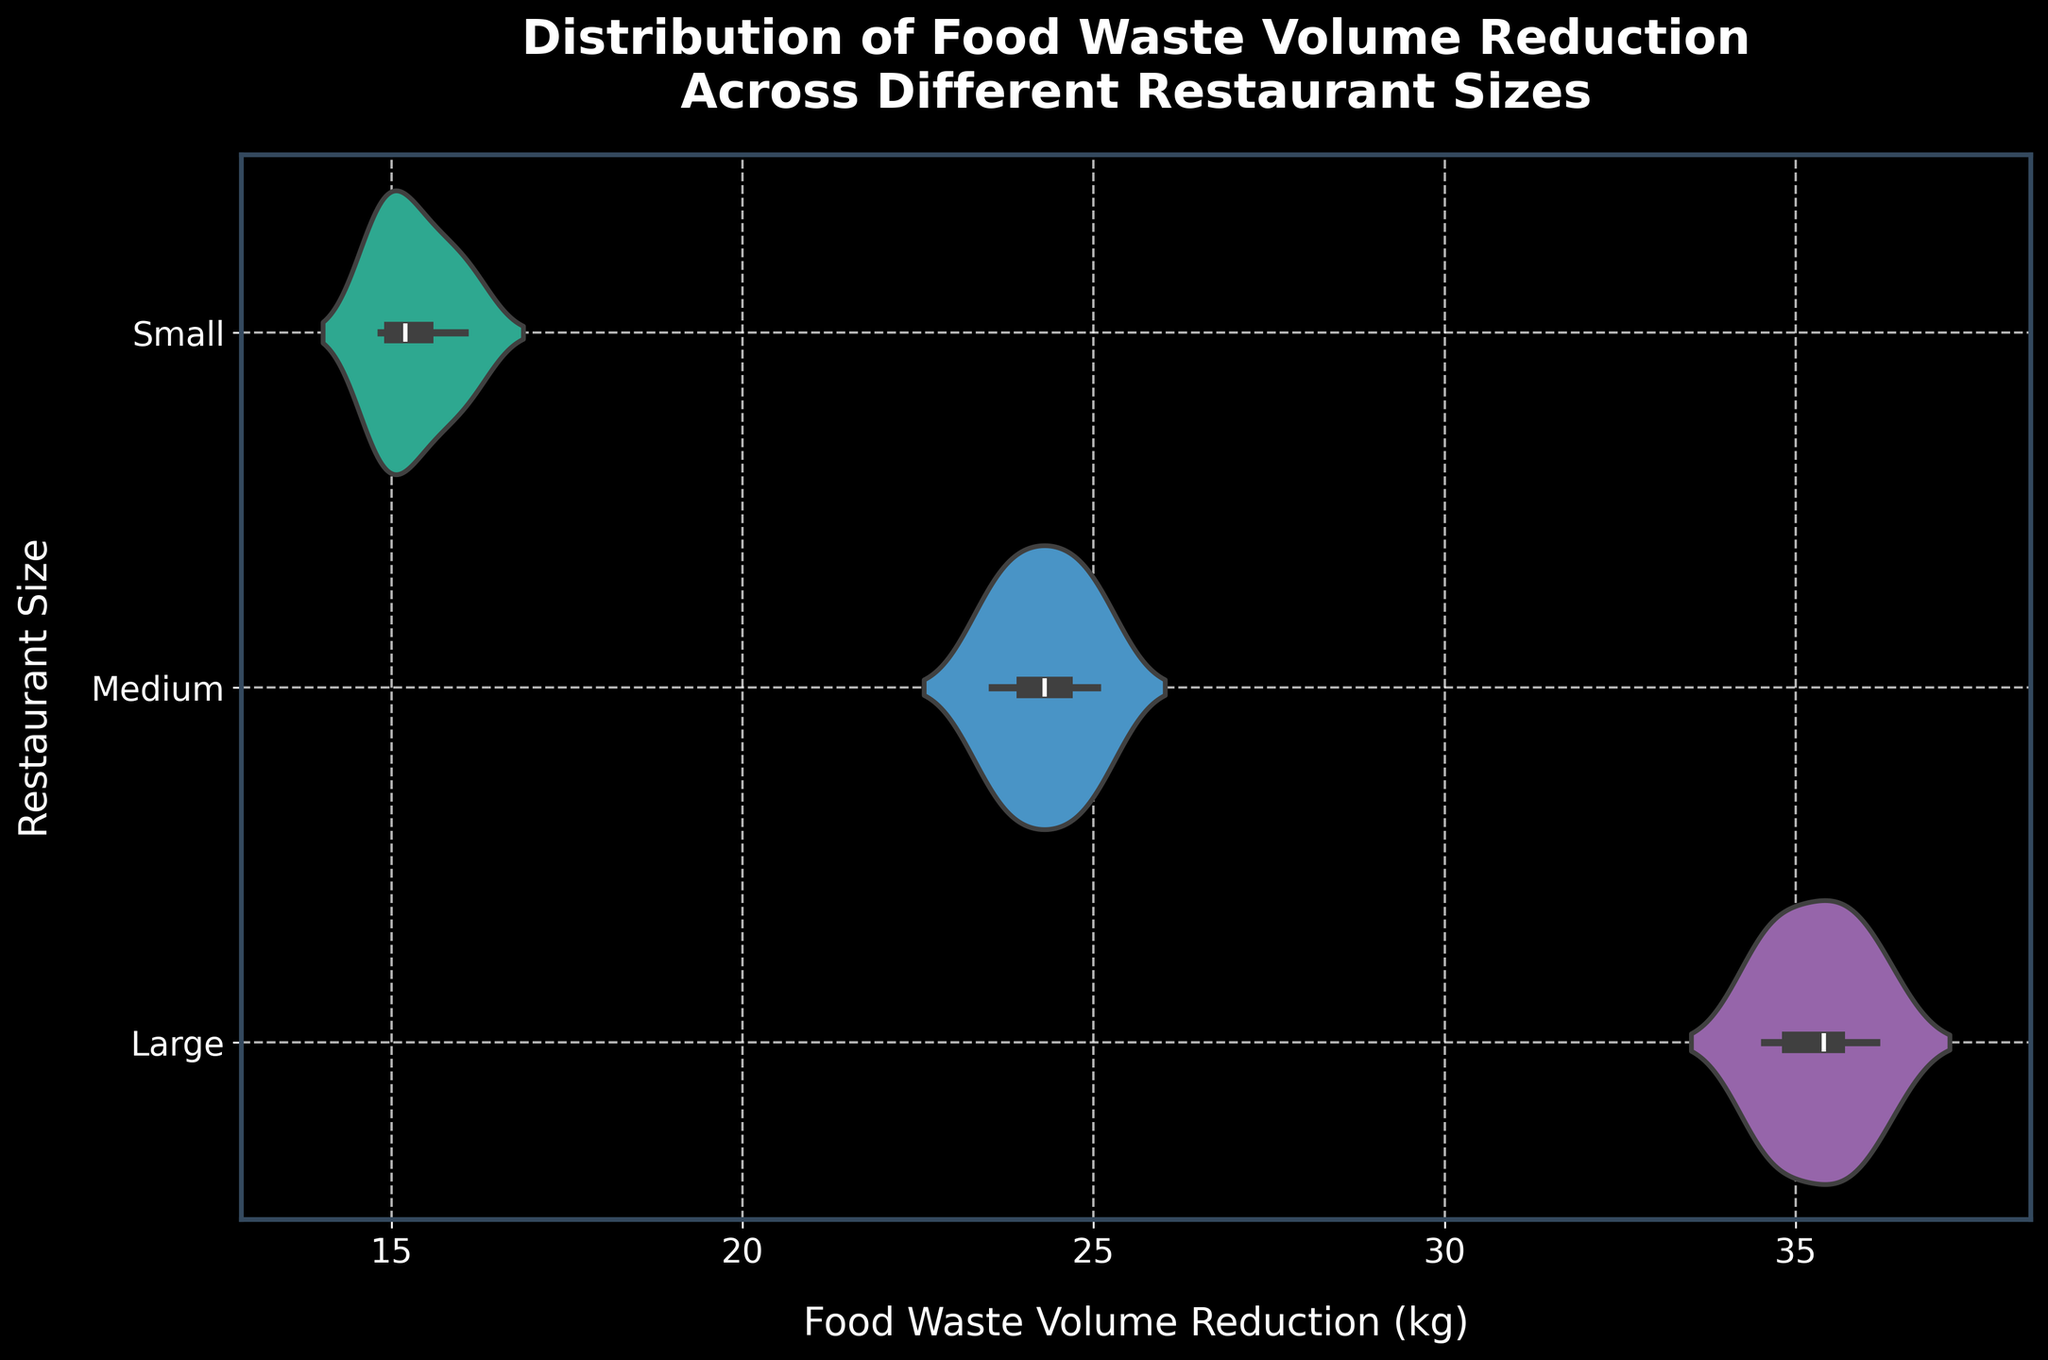1. What is the title of the plot? The title of the plot is located at the top and gives a summary of what the plot represents.
Answer: Distribution of Food Waste Volume Reduction Across Different Restaurant Sizes 2. Which restaurant size has the densest center in terms of food waste volume reduction? The densest center is indicated by the widest part of the violin plot at its center.
Answer: Medium 3. What is the approximate range of food waste volume reduction for large restaurants? The range corresponds to the thickest parts at the top and bottom of the violin plot for large restaurants.
Answer: 34.5 to 36.2 kg 4. How does the food waste volume reduction distribution of small restaurants compare to that of large restaurants in terms of spread? Compare the lengths of the violin plots for the two restaurant sizes to assess the spread.
Answer: Small restaurants have a smaller spread than large restaurants 5. Which restaurant size shows the least variation in food waste volume reduction? The least variation is indicated by the shortest length of the violin plots.
Answer: Small 6. What is the median food waste volume reduction for medium-sized restaurants? The median is shown as a white dot within the box plot inside the violin plot for medium-sized restaurants.
Answer: 24.3 kg 7. How do the medians of food waste volume reduction for small and large restaurants compare? Compare the white dots (medians) within the violin plots of small and large restaurants.
Answer: The median for small restaurants is lower than for large restaurants 8. What color is used to represent large restaurants in the plot? The color of the largest violin plot corresponds to its category (large restaurants).
Answer: Purple 9. What does the inner box within each violin plot signify? The inner box represents the interquartile range, showing where the middle 50% of the data points lie.
Answer: Interquartile range 10. What is the scale used on the x-axis? The x-axis represents the food waste volume reduction in kilograms and is linearly scaled.
Answer: Linear 